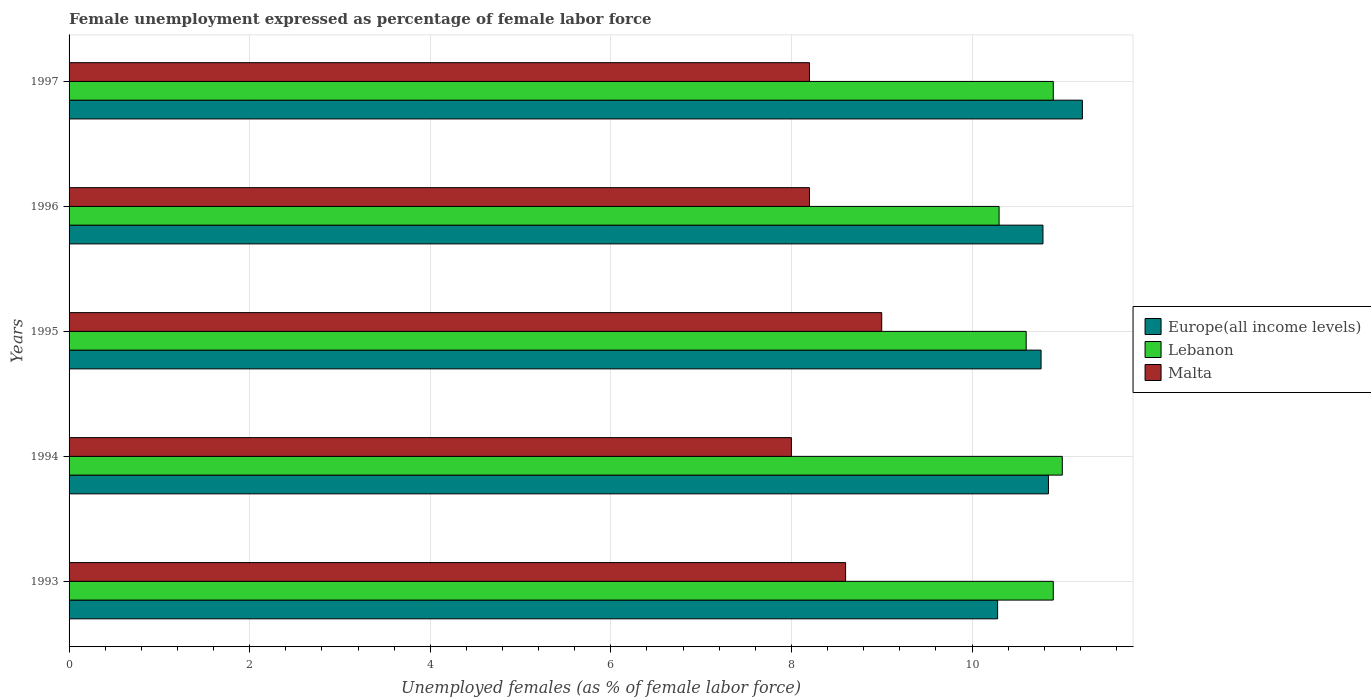How many different coloured bars are there?
Give a very brief answer. 3. How many groups of bars are there?
Give a very brief answer. 5. Are the number of bars per tick equal to the number of legend labels?
Give a very brief answer. Yes. How many bars are there on the 5th tick from the top?
Give a very brief answer. 3. How many bars are there on the 3rd tick from the bottom?
Your answer should be very brief. 3. What is the unemployment in females in in Lebanon in 1996?
Your response must be concise. 10.3. Across all years, what is the maximum unemployment in females in in Europe(all income levels)?
Your response must be concise. 11.22. Across all years, what is the minimum unemployment in females in in Europe(all income levels)?
Make the answer very short. 10.28. What is the total unemployment in females in in Malta in the graph?
Ensure brevity in your answer.  42. What is the difference between the unemployment in females in in Europe(all income levels) in 1995 and that in 1996?
Keep it short and to the point. -0.02. What is the difference between the unemployment in females in in Europe(all income levels) in 1997 and the unemployment in females in in Lebanon in 1995?
Ensure brevity in your answer.  0.62. What is the average unemployment in females in in Europe(all income levels) per year?
Ensure brevity in your answer.  10.78. In the year 1995, what is the difference between the unemployment in females in in Lebanon and unemployment in females in in Europe(all income levels)?
Provide a succinct answer. -0.16. In how many years, is the unemployment in females in in Malta greater than 10 %?
Your response must be concise. 0. What is the difference between the highest and the second highest unemployment in females in in Europe(all income levels)?
Ensure brevity in your answer.  0.38. What does the 2nd bar from the top in 1995 represents?
Offer a very short reply. Lebanon. What does the 1st bar from the bottom in 1995 represents?
Your answer should be very brief. Europe(all income levels). Is it the case that in every year, the sum of the unemployment in females in in Malta and unemployment in females in in Lebanon is greater than the unemployment in females in in Europe(all income levels)?
Your answer should be very brief. Yes. Are all the bars in the graph horizontal?
Your answer should be compact. Yes. How many years are there in the graph?
Make the answer very short. 5. Does the graph contain any zero values?
Keep it short and to the point. No. Where does the legend appear in the graph?
Make the answer very short. Center right. What is the title of the graph?
Offer a very short reply. Female unemployment expressed as percentage of female labor force. What is the label or title of the X-axis?
Ensure brevity in your answer.  Unemployed females (as % of female labor force). What is the Unemployed females (as % of female labor force) in Europe(all income levels) in 1993?
Provide a short and direct response. 10.28. What is the Unemployed females (as % of female labor force) in Lebanon in 1993?
Give a very brief answer. 10.9. What is the Unemployed females (as % of female labor force) of Malta in 1993?
Make the answer very short. 8.6. What is the Unemployed females (as % of female labor force) of Europe(all income levels) in 1994?
Provide a short and direct response. 10.85. What is the Unemployed females (as % of female labor force) of Malta in 1994?
Your response must be concise. 8. What is the Unemployed females (as % of female labor force) in Europe(all income levels) in 1995?
Give a very brief answer. 10.76. What is the Unemployed females (as % of female labor force) in Lebanon in 1995?
Ensure brevity in your answer.  10.6. What is the Unemployed females (as % of female labor force) in Malta in 1995?
Ensure brevity in your answer.  9. What is the Unemployed females (as % of female labor force) of Europe(all income levels) in 1996?
Keep it short and to the point. 10.79. What is the Unemployed females (as % of female labor force) in Lebanon in 1996?
Your answer should be very brief. 10.3. What is the Unemployed females (as % of female labor force) in Malta in 1996?
Make the answer very short. 8.2. What is the Unemployed females (as % of female labor force) in Europe(all income levels) in 1997?
Ensure brevity in your answer.  11.22. What is the Unemployed females (as % of female labor force) of Lebanon in 1997?
Make the answer very short. 10.9. What is the Unemployed females (as % of female labor force) in Malta in 1997?
Provide a succinct answer. 8.2. Across all years, what is the maximum Unemployed females (as % of female labor force) of Europe(all income levels)?
Ensure brevity in your answer.  11.22. Across all years, what is the maximum Unemployed females (as % of female labor force) of Lebanon?
Make the answer very short. 11. Across all years, what is the maximum Unemployed females (as % of female labor force) in Malta?
Provide a short and direct response. 9. Across all years, what is the minimum Unemployed females (as % of female labor force) of Europe(all income levels)?
Provide a succinct answer. 10.28. Across all years, what is the minimum Unemployed females (as % of female labor force) of Lebanon?
Give a very brief answer. 10.3. What is the total Unemployed females (as % of female labor force) of Europe(all income levels) in the graph?
Your answer should be compact. 53.9. What is the total Unemployed females (as % of female labor force) in Lebanon in the graph?
Ensure brevity in your answer.  53.7. What is the difference between the Unemployed females (as % of female labor force) in Europe(all income levels) in 1993 and that in 1994?
Your answer should be very brief. -0.56. What is the difference between the Unemployed females (as % of female labor force) of Malta in 1993 and that in 1994?
Offer a very short reply. 0.6. What is the difference between the Unemployed females (as % of female labor force) of Europe(all income levels) in 1993 and that in 1995?
Provide a succinct answer. -0.48. What is the difference between the Unemployed females (as % of female labor force) in Lebanon in 1993 and that in 1995?
Provide a short and direct response. 0.3. What is the difference between the Unemployed females (as % of female labor force) in Malta in 1993 and that in 1995?
Give a very brief answer. -0.4. What is the difference between the Unemployed females (as % of female labor force) of Europe(all income levels) in 1993 and that in 1996?
Ensure brevity in your answer.  -0.5. What is the difference between the Unemployed females (as % of female labor force) in Europe(all income levels) in 1993 and that in 1997?
Ensure brevity in your answer.  -0.94. What is the difference between the Unemployed females (as % of female labor force) of Lebanon in 1993 and that in 1997?
Make the answer very short. 0. What is the difference between the Unemployed females (as % of female labor force) in Malta in 1993 and that in 1997?
Offer a terse response. 0.4. What is the difference between the Unemployed females (as % of female labor force) in Europe(all income levels) in 1994 and that in 1995?
Give a very brief answer. 0.08. What is the difference between the Unemployed females (as % of female labor force) in Lebanon in 1994 and that in 1995?
Provide a succinct answer. 0.4. What is the difference between the Unemployed females (as % of female labor force) of Europe(all income levels) in 1994 and that in 1996?
Provide a short and direct response. 0.06. What is the difference between the Unemployed females (as % of female labor force) in Lebanon in 1994 and that in 1996?
Keep it short and to the point. 0.7. What is the difference between the Unemployed females (as % of female labor force) of Malta in 1994 and that in 1996?
Offer a very short reply. -0.2. What is the difference between the Unemployed females (as % of female labor force) of Europe(all income levels) in 1994 and that in 1997?
Your response must be concise. -0.38. What is the difference between the Unemployed females (as % of female labor force) of Malta in 1994 and that in 1997?
Make the answer very short. -0.2. What is the difference between the Unemployed females (as % of female labor force) of Europe(all income levels) in 1995 and that in 1996?
Offer a very short reply. -0.02. What is the difference between the Unemployed females (as % of female labor force) in Lebanon in 1995 and that in 1996?
Ensure brevity in your answer.  0.3. What is the difference between the Unemployed females (as % of female labor force) in Malta in 1995 and that in 1996?
Make the answer very short. 0.8. What is the difference between the Unemployed females (as % of female labor force) in Europe(all income levels) in 1995 and that in 1997?
Keep it short and to the point. -0.46. What is the difference between the Unemployed females (as % of female labor force) of Lebanon in 1995 and that in 1997?
Provide a succinct answer. -0.3. What is the difference between the Unemployed females (as % of female labor force) in Europe(all income levels) in 1996 and that in 1997?
Give a very brief answer. -0.44. What is the difference between the Unemployed females (as % of female labor force) of Europe(all income levels) in 1993 and the Unemployed females (as % of female labor force) of Lebanon in 1994?
Give a very brief answer. -0.72. What is the difference between the Unemployed females (as % of female labor force) in Europe(all income levels) in 1993 and the Unemployed females (as % of female labor force) in Malta in 1994?
Offer a very short reply. 2.28. What is the difference between the Unemployed females (as % of female labor force) in Europe(all income levels) in 1993 and the Unemployed females (as % of female labor force) in Lebanon in 1995?
Offer a very short reply. -0.32. What is the difference between the Unemployed females (as % of female labor force) of Europe(all income levels) in 1993 and the Unemployed females (as % of female labor force) of Malta in 1995?
Your response must be concise. 1.28. What is the difference between the Unemployed females (as % of female labor force) of Lebanon in 1993 and the Unemployed females (as % of female labor force) of Malta in 1995?
Give a very brief answer. 1.9. What is the difference between the Unemployed females (as % of female labor force) of Europe(all income levels) in 1993 and the Unemployed females (as % of female labor force) of Lebanon in 1996?
Offer a very short reply. -0.02. What is the difference between the Unemployed females (as % of female labor force) in Europe(all income levels) in 1993 and the Unemployed females (as % of female labor force) in Malta in 1996?
Give a very brief answer. 2.08. What is the difference between the Unemployed females (as % of female labor force) in Lebanon in 1993 and the Unemployed females (as % of female labor force) in Malta in 1996?
Provide a short and direct response. 2.7. What is the difference between the Unemployed females (as % of female labor force) in Europe(all income levels) in 1993 and the Unemployed females (as % of female labor force) in Lebanon in 1997?
Offer a very short reply. -0.62. What is the difference between the Unemployed females (as % of female labor force) in Europe(all income levels) in 1993 and the Unemployed females (as % of female labor force) in Malta in 1997?
Your answer should be compact. 2.08. What is the difference between the Unemployed females (as % of female labor force) of Europe(all income levels) in 1994 and the Unemployed females (as % of female labor force) of Lebanon in 1995?
Offer a terse response. 0.25. What is the difference between the Unemployed females (as % of female labor force) of Europe(all income levels) in 1994 and the Unemployed females (as % of female labor force) of Malta in 1995?
Your response must be concise. 1.85. What is the difference between the Unemployed females (as % of female labor force) in Europe(all income levels) in 1994 and the Unemployed females (as % of female labor force) in Lebanon in 1996?
Offer a terse response. 0.55. What is the difference between the Unemployed females (as % of female labor force) of Europe(all income levels) in 1994 and the Unemployed females (as % of female labor force) of Malta in 1996?
Offer a terse response. 2.65. What is the difference between the Unemployed females (as % of female labor force) in Europe(all income levels) in 1994 and the Unemployed females (as % of female labor force) in Lebanon in 1997?
Offer a very short reply. -0.05. What is the difference between the Unemployed females (as % of female labor force) in Europe(all income levels) in 1994 and the Unemployed females (as % of female labor force) in Malta in 1997?
Your answer should be very brief. 2.65. What is the difference between the Unemployed females (as % of female labor force) in Europe(all income levels) in 1995 and the Unemployed females (as % of female labor force) in Lebanon in 1996?
Offer a terse response. 0.46. What is the difference between the Unemployed females (as % of female labor force) of Europe(all income levels) in 1995 and the Unemployed females (as % of female labor force) of Malta in 1996?
Make the answer very short. 2.56. What is the difference between the Unemployed females (as % of female labor force) of Lebanon in 1995 and the Unemployed females (as % of female labor force) of Malta in 1996?
Provide a succinct answer. 2.4. What is the difference between the Unemployed females (as % of female labor force) in Europe(all income levels) in 1995 and the Unemployed females (as % of female labor force) in Lebanon in 1997?
Keep it short and to the point. -0.14. What is the difference between the Unemployed females (as % of female labor force) in Europe(all income levels) in 1995 and the Unemployed females (as % of female labor force) in Malta in 1997?
Ensure brevity in your answer.  2.56. What is the difference between the Unemployed females (as % of female labor force) in Europe(all income levels) in 1996 and the Unemployed females (as % of female labor force) in Lebanon in 1997?
Offer a very short reply. -0.11. What is the difference between the Unemployed females (as % of female labor force) in Europe(all income levels) in 1996 and the Unemployed females (as % of female labor force) in Malta in 1997?
Make the answer very short. 2.59. What is the difference between the Unemployed females (as % of female labor force) of Lebanon in 1996 and the Unemployed females (as % of female labor force) of Malta in 1997?
Make the answer very short. 2.1. What is the average Unemployed females (as % of female labor force) in Europe(all income levels) per year?
Make the answer very short. 10.78. What is the average Unemployed females (as % of female labor force) of Lebanon per year?
Offer a very short reply. 10.74. What is the average Unemployed females (as % of female labor force) of Malta per year?
Keep it short and to the point. 8.4. In the year 1993, what is the difference between the Unemployed females (as % of female labor force) of Europe(all income levels) and Unemployed females (as % of female labor force) of Lebanon?
Make the answer very short. -0.62. In the year 1993, what is the difference between the Unemployed females (as % of female labor force) of Europe(all income levels) and Unemployed females (as % of female labor force) of Malta?
Provide a short and direct response. 1.68. In the year 1993, what is the difference between the Unemployed females (as % of female labor force) in Lebanon and Unemployed females (as % of female labor force) in Malta?
Offer a very short reply. 2.3. In the year 1994, what is the difference between the Unemployed females (as % of female labor force) of Europe(all income levels) and Unemployed females (as % of female labor force) of Lebanon?
Ensure brevity in your answer.  -0.15. In the year 1994, what is the difference between the Unemployed females (as % of female labor force) of Europe(all income levels) and Unemployed females (as % of female labor force) of Malta?
Give a very brief answer. 2.85. In the year 1994, what is the difference between the Unemployed females (as % of female labor force) in Lebanon and Unemployed females (as % of female labor force) in Malta?
Provide a succinct answer. 3. In the year 1995, what is the difference between the Unemployed females (as % of female labor force) in Europe(all income levels) and Unemployed females (as % of female labor force) in Lebanon?
Your response must be concise. 0.16. In the year 1995, what is the difference between the Unemployed females (as % of female labor force) of Europe(all income levels) and Unemployed females (as % of female labor force) of Malta?
Offer a terse response. 1.76. In the year 1995, what is the difference between the Unemployed females (as % of female labor force) of Lebanon and Unemployed females (as % of female labor force) of Malta?
Your answer should be very brief. 1.6. In the year 1996, what is the difference between the Unemployed females (as % of female labor force) of Europe(all income levels) and Unemployed females (as % of female labor force) of Lebanon?
Provide a short and direct response. 0.49. In the year 1996, what is the difference between the Unemployed females (as % of female labor force) of Europe(all income levels) and Unemployed females (as % of female labor force) of Malta?
Provide a short and direct response. 2.59. In the year 1996, what is the difference between the Unemployed females (as % of female labor force) in Lebanon and Unemployed females (as % of female labor force) in Malta?
Provide a succinct answer. 2.1. In the year 1997, what is the difference between the Unemployed females (as % of female labor force) of Europe(all income levels) and Unemployed females (as % of female labor force) of Lebanon?
Make the answer very short. 0.32. In the year 1997, what is the difference between the Unemployed females (as % of female labor force) in Europe(all income levels) and Unemployed females (as % of female labor force) in Malta?
Keep it short and to the point. 3.02. In the year 1997, what is the difference between the Unemployed females (as % of female labor force) in Lebanon and Unemployed females (as % of female labor force) in Malta?
Your response must be concise. 2.7. What is the ratio of the Unemployed females (as % of female labor force) in Europe(all income levels) in 1993 to that in 1994?
Make the answer very short. 0.95. What is the ratio of the Unemployed females (as % of female labor force) of Lebanon in 1993 to that in 1994?
Your answer should be compact. 0.99. What is the ratio of the Unemployed females (as % of female labor force) of Malta in 1993 to that in 1994?
Provide a short and direct response. 1.07. What is the ratio of the Unemployed females (as % of female labor force) of Europe(all income levels) in 1993 to that in 1995?
Give a very brief answer. 0.96. What is the ratio of the Unemployed females (as % of female labor force) of Lebanon in 1993 to that in 1995?
Make the answer very short. 1.03. What is the ratio of the Unemployed females (as % of female labor force) of Malta in 1993 to that in 1995?
Your answer should be compact. 0.96. What is the ratio of the Unemployed females (as % of female labor force) of Europe(all income levels) in 1993 to that in 1996?
Offer a terse response. 0.95. What is the ratio of the Unemployed females (as % of female labor force) of Lebanon in 1993 to that in 1996?
Make the answer very short. 1.06. What is the ratio of the Unemployed females (as % of female labor force) in Malta in 1993 to that in 1996?
Your answer should be compact. 1.05. What is the ratio of the Unemployed females (as % of female labor force) of Europe(all income levels) in 1993 to that in 1997?
Offer a very short reply. 0.92. What is the ratio of the Unemployed females (as % of female labor force) of Malta in 1993 to that in 1997?
Keep it short and to the point. 1.05. What is the ratio of the Unemployed females (as % of female labor force) of Europe(all income levels) in 1994 to that in 1995?
Your answer should be very brief. 1.01. What is the ratio of the Unemployed females (as % of female labor force) of Lebanon in 1994 to that in 1995?
Offer a very short reply. 1.04. What is the ratio of the Unemployed females (as % of female labor force) in Europe(all income levels) in 1994 to that in 1996?
Ensure brevity in your answer.  1.01. What is the ratio of the Unemployed females (as % of female labor force) in Lebanon in 1994 to that in 1996?
Ensure brevity in your answer.  1.07. What is the ratio of the Unemployed females (as % of female labor force) in Malta in 1994 to that in 1996?
Your answer should be compact. 0.98. What is the ratio of the Unemployed females (as % of female labor force) of Europe(all income levels) in 1994 to that in 1997?
Your answer should be compact. 0.97. What is the ratio of the Unemployed females (as % of female labor force) in Lebanon in 1994 to that in 1997?
Provide a succinct answer. 1.01. What is the ratio of the Unemployed females (as % of female labor force) in Malta in 1994 to that in 1997?
Your answer should be compact. 0.98. What is the ratio of the Unemployed females (as % of female labor force) in Europe(all income levels) in 1995 to that in 1996?
Your answer should be compact. 1. What is the ratio of the Unemployed females (as % of female labor force) of Lebanon in 1995 to that in 1996?
Your response must be concise. 1.03. What is the ratio of the Unemployed females (as % of female labor force) of Malta in 1995 to that in 1996?
Offer a terse response. 1.1. What is the ratio of the Unemployed females (as % of female labor force) in Europe(all income levels) in 1995 to that in 1997?
Offer a terse response. 0.96. What is the ratio of the Unemployed females (as % of female labor force) of Lebanon in 1995 to that in 1997?
Provide a short and direct response. 0.97. What is the ratio of the Unemployed females (as % of female labor force) in Malta in 1995 to that in 1997?
Make the answer very short. 1.1. What is the ratio of the Unemployed females (as % of female labor force) in Europe(all income levels) in 1996 to that in 1997?
Give a very brief answer. 0.96. What is the ratio of the Unemployed females (as % of female labor force) of Lebanon in 1996 to that in 1997?
Provide a short and direct response. 0.94. What is the ratio of the Unemployed females (as % of female labor force) in Malta in 1996 to that in 1997?
Ensure brevity in your answer.  1. What is the difference between the highest and the second highest Unemployed females (as % of female labor force) in Europe(all income levels)?
Your answer should be very brief. 0.38. What is the difference between the highest and the second highest Unemployed females (as % of female labor force) of Lebanon?
Your response must be concise. 0.1. What is the difference between the highest and the lowest Unemployed females (as % of female labor force) of Europe(all income levels)?
Provide a succinct answer. 0.94. What is the difference between the highest and the lowest Unemployed females (as % of female labor force) of Lebanon?
Offer a terse response. 0.7. 